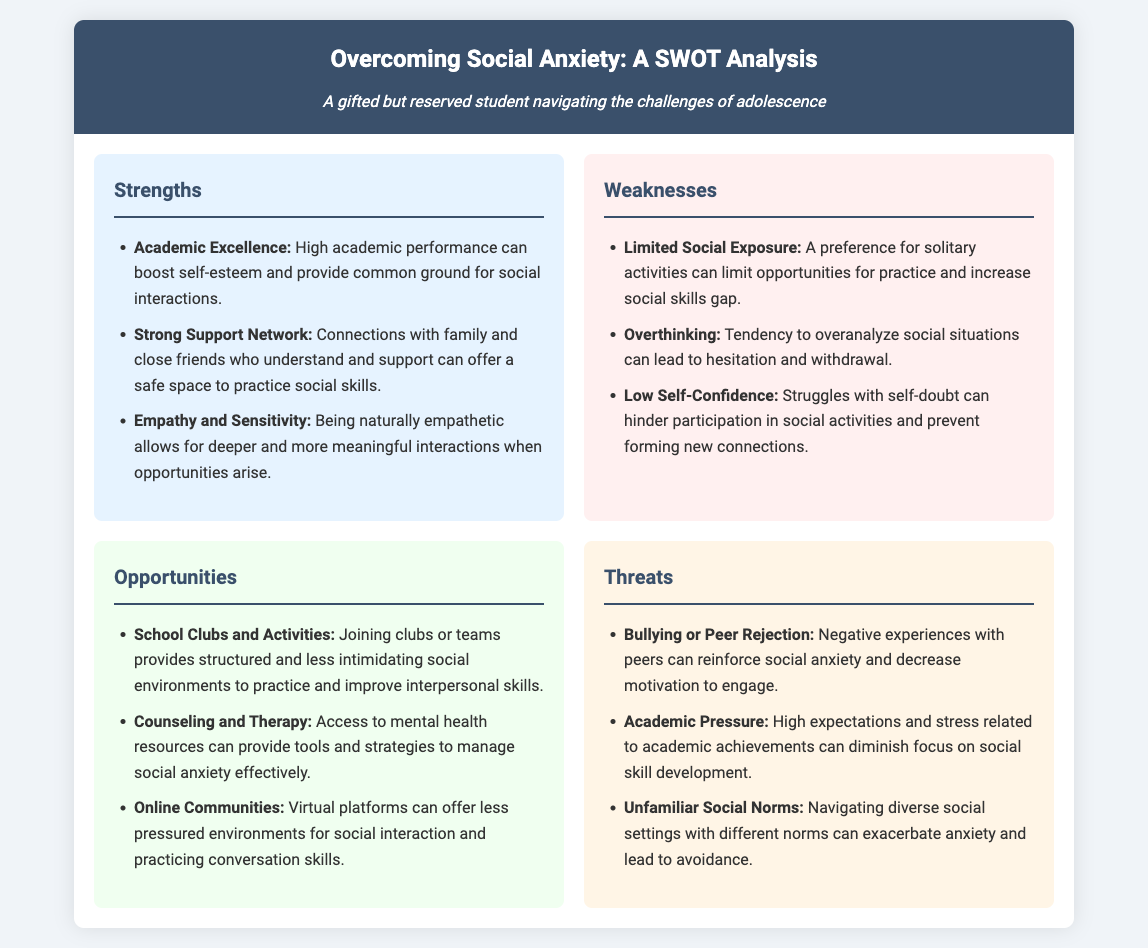What are the strengths listed in the analysis? The strengths section includes academic excellence, strong support network, and empathy and sensitivity.
Answer: academic excellence, strong support network, empathy and sensitivity What is a weakness related to social exposure? The weaknesses section mentions limited social exposure as a key factor affecting confidence.
Answer: Limited Social Exposure How many opportunities are listed in the document? There are three opportunities mentioned in the opportunities section.
Answer: 3 What is one opportunity for overcoming social anxiety? The opportunities section lists school clubs and activities as a viable option for practice.
Answer: School Clubs and Activities What threat is associated with peer dynamics? The threats section mentions bullying or peer rejection as an influence on social anxiety.
Answer: Bullying or Peer Rejection Which strength can enhance the quality of interactions? Empathy and sensitivity are noted as strengths that deepen interactions.
Answer: Empathy and Sensitivity What aspect can contribute to low self-confidence? The weaknesses section highlights struggles with self-doubt as a contributing factor.
Answer: Low Self-Confidence What can help manage social anxiety effectively? Counseling and therapy are suggested as opportunities for effective management of social anxiety.
Answer: Counseling and Therapy 